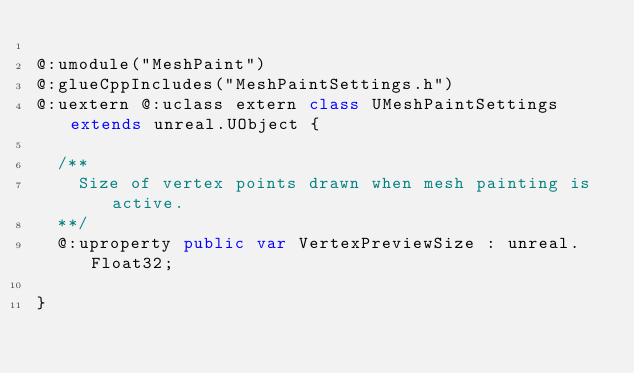Convert code to text. <code><loc_0><loc_0><loc_500><loc_500><_Haxe_>
@:umodule("MeshPaint")
@:glueCppIncludes("MeshPaintSettings.h")
@:uextern @:uclass extern class UMeshPaintSettings extends unreal.UObject {
  
  /**
    Size of vertex points drawn when mesh painting is active.
  **/
  @:uproperty public var VertexPreviewSize : unreal.Float32;
  
}
</code> 